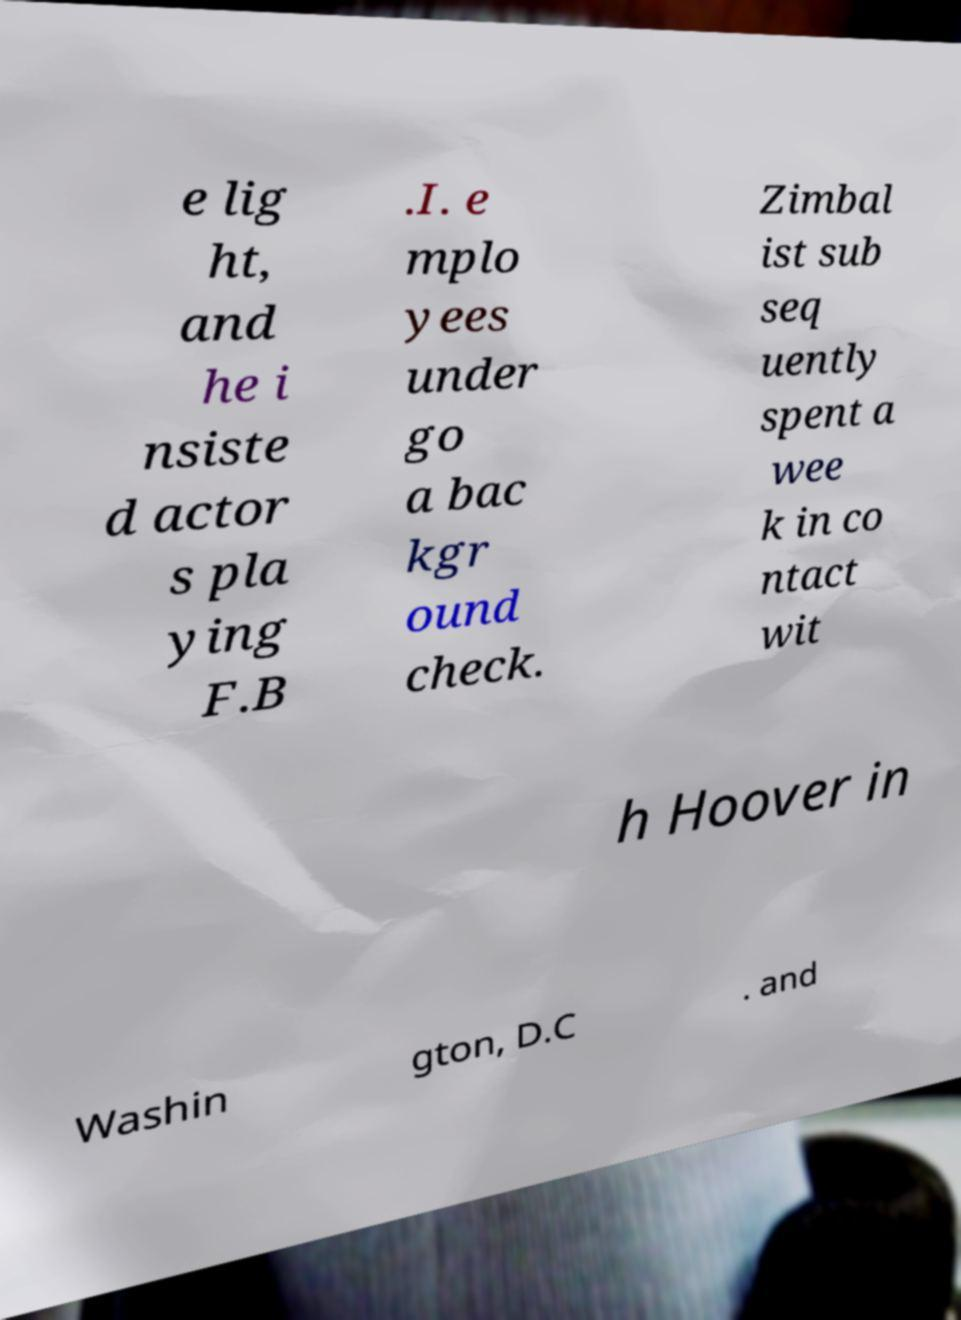Can you read and provide the text displayed in the image?This photo seems to have some interesting text. Can you extract and type it out for me? e lig ht, and he i nsiste d actor s pla ying F.B .I. e mplo yees under go a bac kgr ound check. Zimbal ist sub seq uently spent a wee k in co ntact wit h Hoover in Washin gton, D.C . and 